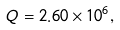<formula> <loc_0><loc_0><loc_500><loc_500>Q = 2 . 6 0 \times 1 0 ^ { 6 } ,</formula> 